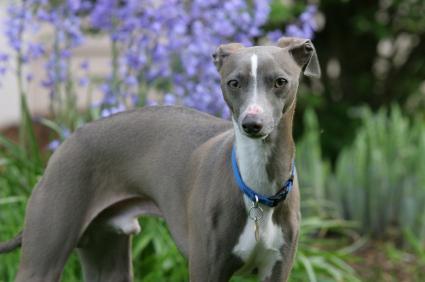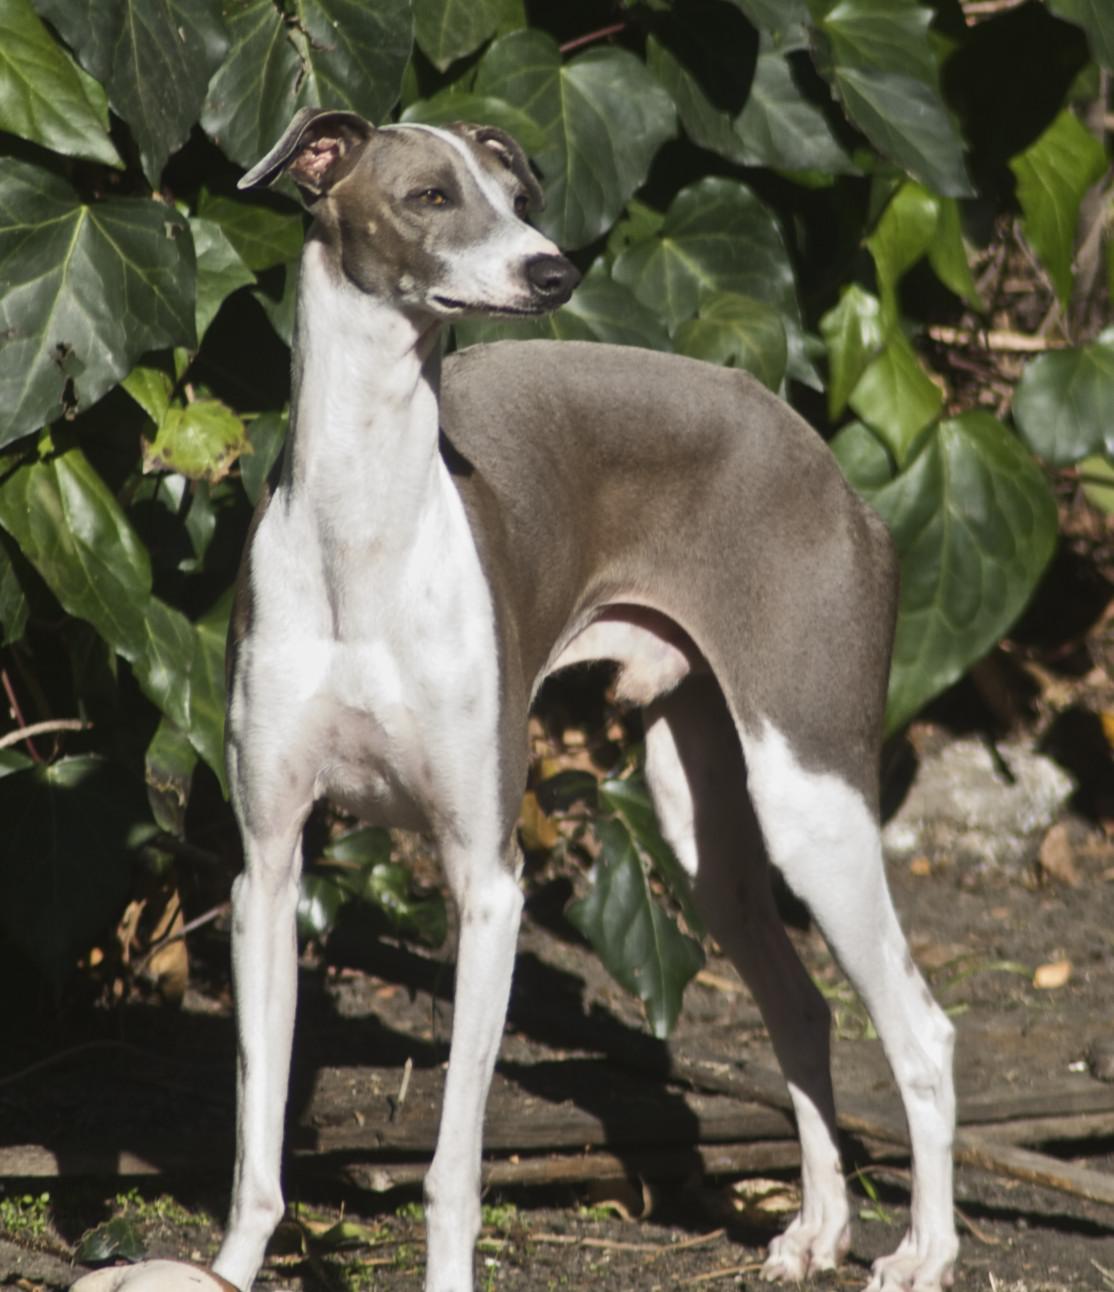The first image is the image on the left, the second image is the image on the right. Evaluate the accuracy of this statement regarding the images: "The dog in the image on the left is wearing a collar.". Is it true? Answer yes or no. Yes. 